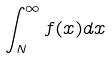Convert formula to latex. <formula><loc_0><loc_0><loc_500><loc_500>\int _ { N } ^ { \infty } f ( x ) d x</formula> 